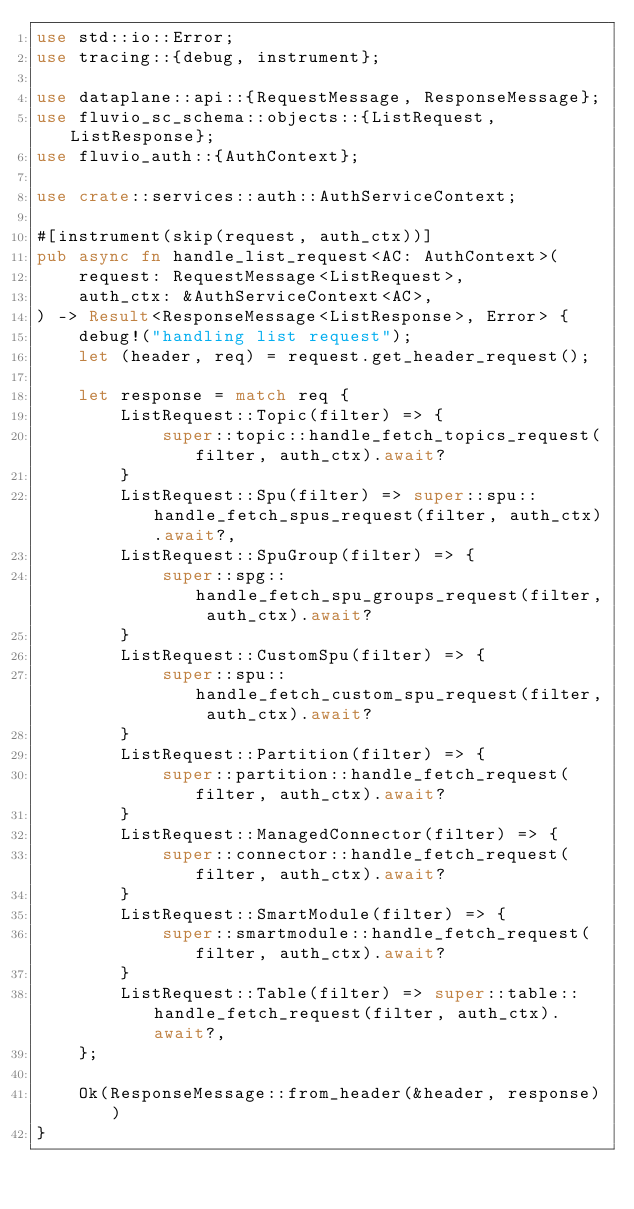<code> <loc_0><loc_0><loc_500><loc_500><_Rust_>use std::io::Error;
use tracing::{debug, instrument};

use dataplane::api::{RequestMessage, ResponseMessage};
use fluvio_sc_schema::objects::{ListRequest, ListResponse};
use fluvio_auth::{AuthContext};

use crate::services::auth::AuthServiceContext;

#[instrument(skip(request, auth_ctx))]
pub async fn handle_list_request<AC: AuthContext>(
    request: RequestMessage<ListRequest>,
    auth_ctx: &AuthServiceContext<AC>,
) -> Result<ResponseMessage<ListResponse>, Error> {
    debug!("handling list request");
    let (header, req) = request.get_header_request();

    let response = match req {
        ListRequest::Topic(filter) => {
            super::topic::handle_fetch_topics_request(filter, auth_ctx).await?
        }
        ListRequest::Spu(filter) => super::spu::handle_fetch_spus_request(filter, auth_ctx).await?,
        ListRequest::SpuGroup(filter) => {
            super::spg::handle_fetch_spu_groups_request(filter, auth_ctx).await?
        }
        ListRequest::CustomSpu(filter) => {
            super::spu::handle_fetch_custom_spu_request(filter, auth_ctx).await?
        }
        ListRequest::Partition(filter) => {
            super::partition::handle_fetch_request(filter, auth_ctx).await?
        }
        ListRequest::ManagedConnector(filter) => {
            super::connector::handle_fetch_request(filter, auth_ctx).await?
        }
        ListRequest::SmartModule(filter) => {
            super::smartmodule::handle_fetch_request(filter, auth_ctx).await?
        }
        ListRequest::Table(filter) => super::table::handle_fetch_request(filter, auth_ctx).await?,
    };

    Ok(ResponseMessage::from_header(&header, response))
}
</code> 